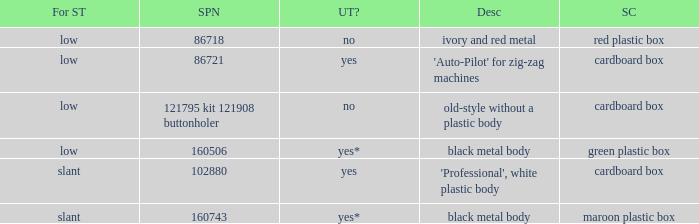What's the description of the buttonholer whose singer part number is 121795 kit 121908 buttonholer? Old-style without a plastic body. 